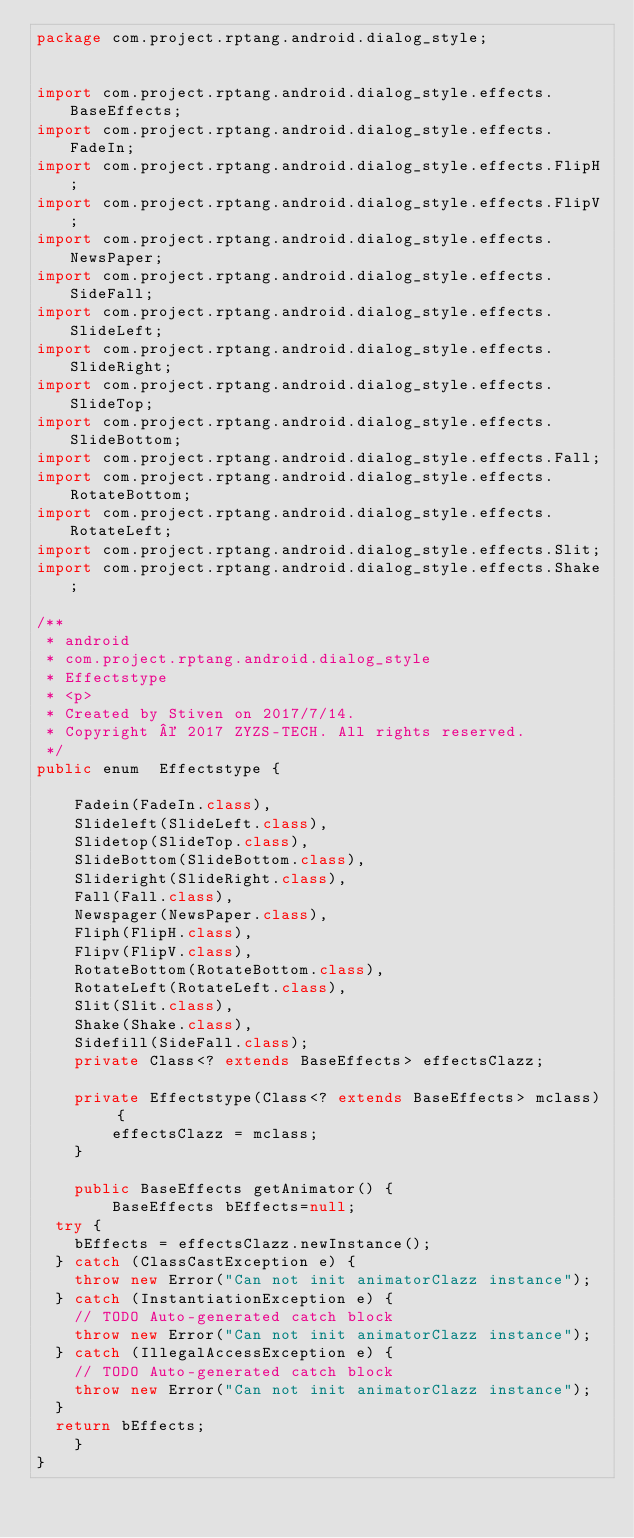Convert code to text. <code><loc_0><loc_0><loc_500><loc_500><_Java_>package com.project.rptang.android.dialog_style;


import com.project.rptang.android.dialog_style.effects.BaseEffects;
import com.project.rptang.android.dialog_style.effects.FadeIn;
import com.project.rptang.android.dialog_style.effects.FlipH;
import com.project.rptang.android.dialog_style.effects.FlipV;
import com.project.rptang.android.dialog_style.effects.NewsPaper;
import com.project.rptang.android.dialog_style.effects.SideFall;
import com.project.rptang.android.dialog_style.effects.SlideLeft;
import com.project.rptang.android.dialog_style.effects.SlideRight;
import com.project.rptang.android.dialog_style.effects.SlideTop;
import com.project.rptang.android.dialog_style.effects.SlideBottom;
import com.project.rptang.android.dialog_style.effects.Fall;
import com.project.rptang.android.dialog_style.effects.RotateBottom;
import com.project.rptang.android.dialog_style.effects.RotateLeft;
import com.project.rptang.android.dialog_style.effects.Slit;
import com.project.rptang.android.dialog_style.effects.Shake;

/**
 * android
 * com.project.rptang.android.dialog_style
 * Effectstype
 * <p>
 * Created by Stiven on 2017/7/14.
 * Copyright © 2017 ZYZS-TECH. All rights reserved.
 */
public enum  Effectstype {

    Fadein(FadeIn.class),
    Slideleft(SlideLeft.class),
    Slidetop(SlideTop.class),
    SlideBottom(SlideBottom.class),
    Slideright(SlideRight.class),
    Fall(Fall.class),
    Newspager(NewsPaper.class),
    Fliph(FlipH.class),
    Flipv(FlipV.class),
    RotateBottom(RotateBottom.class),
    RotateLeft(RotateLeft.class),
    Slit(Slit.class),
    Shake(Shake.class),
    Sidefill(SideFall.class);
    private Class<? extends BaseEffects> effectsClazz;

    private Effectstype(Class<? extends BaseEffects> mclass) {
        effectsClazz = mclass;
    }

    public BaseEffects getAnimator() {
        BaseEffects bEffects=null;
	try {
		bEffects = effectsClazz.newInstance();
	} catch (ClassCastException e) {
		throw new Error("Can not init animatorClazz instance");
	} catch (InstantiationException e) {
		// TODO Auto-generated catch block
		throw new Error("Can not init animatorClazz instance");
	} catch (IllegalAccessException e) {
		// TODO Auto-generated catch block
		throw new Error("Can not init animatorClazz instance");
	}
	return bEffects;
    }
}
</code> 